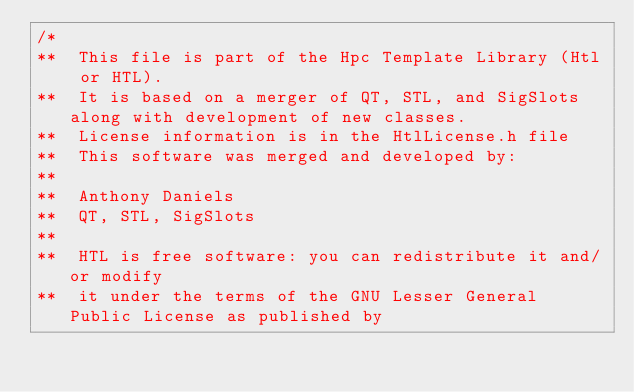<code> <loc_0><loc_0><loc_500><loc_500><_C++_>/*
**	This file is part of the Hpc Template Library (Htl or HTL).
**  It is based on a merger of QT, STL, and SigSlots along with development of new classes.
**  License information is in the HtlLicense.h file
**	This software was merged and developed by:
**	
**  Anthony Daniels
**	QT, STL, SigSlots
**
**  HTL is free software: you can redistribute it and/or modify
**  it under the terms of the GNU Lesser General Public License as published by</code> 